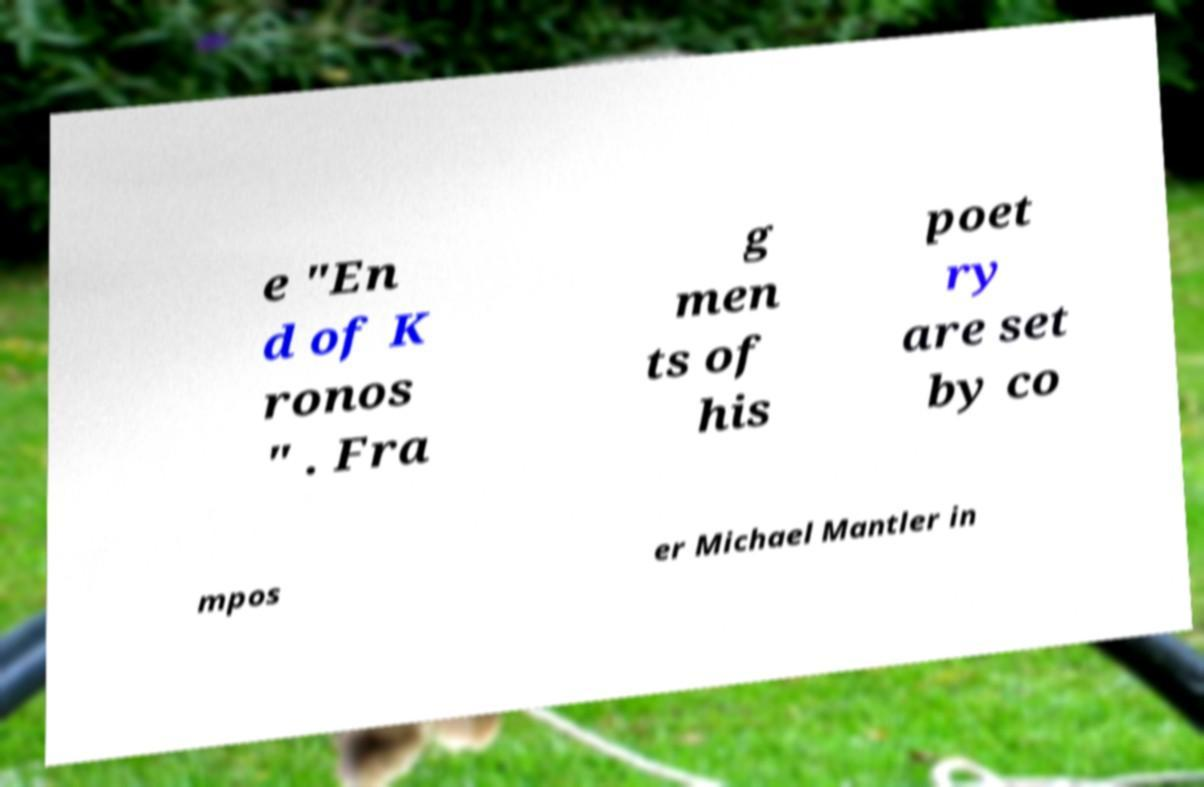Please identify and transcribe the text found in this image. e "En d of K ronos " . Fra g men ts of his poet ry are set by co mpos er Michael Mantler in 